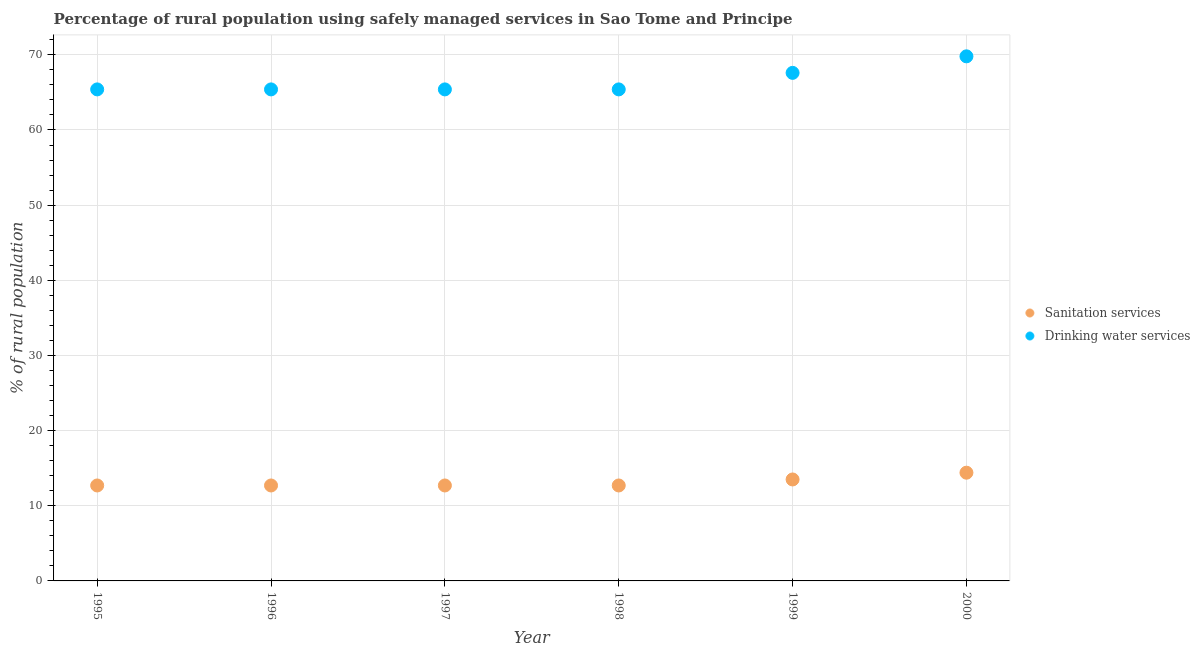How many different coloured dotlines are there?
Ensure brevity in your answer.  2. What is the percentage of rural population who used drinking water services in 2000?
Offer a terse response. 69.8. Across all years, what is the maximum percentage of rural population who used drinking water services?
Provide a short and direct response. 69.8. Across all years, what is the minimum percentage of rural population who used sanitation services?
Offer a terse response. 12.7. In which year was the percentage of rural population who used sanitation services minimum?
Your response must be concise. 1995. What is the total percentage of rural population who used drinking water services in the graph?
Ensure brevity in your answer.  399. What is the difference between the percentage of rural population who used drinking water services in 1995 and that in 1999?
Offer a terse response. -2.2. What is the difference between the percentage of rural population who used sanitation services in 2000 and the percentage of rural population who used drinking water services in 1995?
Your answer should be very brief. -51. What is the average percentage of rural population who used sanitation services per year?
Keep it short and to the point. 13.12. In the year 1997, what is the difference between the percentage of rural population who used sanitation services and percentage of rural population who used drinking water services?
Offer a very short reply. -52.7. What is the ratio of the percentage of rural population who used sanitation services in 1995 to that in 1998?
Provide a short and direct response. 1. Is the percentage of rural population who used drinking water services in 1995 less than that in 1999?
Keep it short and to the point. Yes. Is the difference between the percentage of rural population who used drinking water services in 1995 and 1998 greater than the difference between the percentage of rural population who used sanitation services in 1995 and 1998?
Your response must be concise. No. What is the difference between the highest and the second highest percentage of rural population who used drinking water services?
Make the answer very short. 2.2. What is the difference between the highest and the lowest percentage of rural population who used sanitation services?
Make the answer very short. 1.7. Does the percentage of rural population who used sanitation services monotonically increase over the years?
Provide a succinct answer. No. How many dotlines are there?
Your answer should be very brief. 2. What is the difference between two consecutive major ticks on the Y-axis?
Your answer should be very brief. 10. Are the values on the major ticks of Y-axis written in scientific E-notation?
Offer a terse response. No. Does the graph contain any zero values?
Make the answer very short. No. Does the graph contain grids?
Offer a very short reply. Yes. How many legend labels are there?
Keep it short and to the point. 2. What is the title of the graph?
Keep it short and to the point. Percentage of rural population using safely managed services in Sao Tome and Principe. Does "From production" appear as one of the legend labels in the graph?
Offer a terse response. No. What is the label or title of the Y-axis?
Your response must be concise. % of rural population. What is the % of rural population of Drinking water services in 1995?
Ensure brevity in your answer.  65.4. What is the % of rural population of Sanitation services in 1996?
Provide a short and direct response. 12.7. What is the % of rural population in Drinking water services in 1996?
Offer a very short reply. 65.4. What is the % of rural population of Drinking water services in 1997?
Provide a short and direct response. 65.4. What is the % of rural population of Drinking water services in 1998?
Your answer should be very brief. 65.4. What is the % of rural population in Sanitation services in 1999?
Offer a terse response. 13.5. What is the % of rural population in Drinking water services in 1999?
Offer a terse response. 67.6. What is the % of rural population in Sanitation services in 2000?
Provide a short and direct response. 14.4. What is the % of rural population in Drinking water services in 2000?
Keep it short and to the point. 69.8. Across all years, what is the maximum % of rural population in Drinking water services?
Offer a very short reply. 69.8. Across all years, what is the minimum % of rural population of Sanitation services?
Keep it short and to the point. 12.7. Across all years, what is the minimum % of rural population of Drinking water services?
Make the answer very short. 65.4. What is the total % of rural population in Sanitation services in the graph?
Provide a succinct answer. 78.7. What is the total % of rural population of Drinking water services in the graph?
Make the answer very short. 399. What is the difference between the % of rural population of Drinking water services in 1995 and that in 1996?
Your response must be concise. 0. What is the difference between the % of rural population in Sanitation services in 1995 and that in 1997?
Keep it short and to the point. 0. What is the difference between the % of rural population of Drinking water services in 1995 and that in 1997?
Give a very brief answer. 0. What is the difference between the % of rural population of Sanitation services in 1995 and that in 1998?
Keep it short and to the point. 0. What is the difference between the % of rural population in Sanitation services in 1995 and that in 1999?
Offer a terse response. -0.8. What is the difference between the % of rural population of Sanitation services in 1995 and that in 2000?
Offer a terse response. -1.7. What is the difference between the % of rural population of Drinking water services in 1995 and that in 2000?
Keep it short and to the point. -4.4. What is the difference between the % of rural population in Drinking water services in 1996 and that in 1997?
Provide a succinct answer. 0. What is the difference between the % of rural population of Sanitation services in 1996 and that in 1999?
Offer a very short reply. -0.8. What is the difference between the % of rural population in Sanitation services in 1997 and that in 2000?
Your response must be concise. -1.7. What is the difference between the % of rural population in Drinking water services in 1997 and that in 2000?
Your response must be concise. -4.4. What is the difference between the % of rural population in Sanitation services in 1999 and that in 2000?
Make the answer very short. -0.9. What is the difference between the % of rural population in Drinking water services in 1999 and that in 2000?
Provide a succinct answer. -2.2. What is the difference between the % of rural population of Sanitation services in 1995 and the % of rural population of Drinking water services in 1996?
Offer a very short reply. -52.7. What is the difference between the % of rural population of Sanitation services in 1995 and the % of rural population of Drinking water services in 1997?
Offer a terse response. -52.7. What is the difference between the % of rural population in Sanitation services in 1995 and the % of rural population in Drinking water services in 1998?
Offer a very short reply. -52.7. What is the difference between the % of rural population in Sanitation services in 1995 and the % of rural population in Drinking water services in 1999?
Provide a succinct answer. -54.9. What is the difference between the % of rural population in Sanitation services in 1995 and the % of rural population in Drinking water services in 2000?
Ensure brevity in your answer.  -57.1. What is the difference between the % of rural population in Sanitation services in 1996 and the % of rural population in Drinking water services in 1997?
Provide a succinct answer. -52.7. What is the difference between the % of rural population in Sanitation services in 1996 and the % of rural population in Drinking water services in 1998?
Provide a succinct answer. -52.7. What is the difference between the % of rural population of Sanitation services in 1996 and the % of rural population of Drinking water services in 1999?
Your answer should be compact. -54.9. What is the difference between the % of rural population in Sanitation services in 1996 and the % of rural population in Drinking water services in 2000?
Your response must be concise. -57.1. What is the difference between the % of rural population in Sanitation services in 1997 and the % of rural population in Drinking water services in 1998?
Provide a short and direct response. -52.7. What is the difference between the % of rural population in Sanitation services in 1997 and the % of rural population in Drinking water services in 1999?
Ensure brevity in your answer.  -54.9. What is the difference between the % of rural population in Sanitation services in 1997 and the % of rural population in Drinking water services in 2000?
Provide a short and direct response. -57.1. What is the difference between the % of rural population of Sanitation services in 1998 and the % of rural population of Drinking water services in 1999?
Keep it short and to the point. -54.9. What is the difference between the % of rural population of Sanitation services in 1998 and the % of rural population of Drinking water services in 2000?
Ensure brevity in your answer.  -57.1. What is the difference between the % of rural population in Sanitation services in 1999 and the % of rural population in Drinking water services in 2000?
Give a very brief answer. -56.3. What is the average % of rural population of Sanitation services per year?
Your response must be concise. 13.12. What is the average % of rural population in Drinking water services per year?
Your answer should be very brief. 66.5. In the year 1995, what is the difference between the % of rural population in Sanitation services and % of rural population in Drinking water services?
Your answer should be compact. -52.7. In the year 1996, what is the difference between the % of rural population in Sanitation services and % of rural population in Drinking water services?
Your answer should be compact. -52.7. In the year 1997, what is the difference between the % of rural population of Sanitation services and % of rural population of Drinking water services?
Your answer should be very brief. -52.7. In the year 1998, what is the difference between the % of rural population in Sanitation services and % of rural population in Drinking water services?
Your answer should be compact. -52.7. In the year 1999, what is the difference between the % of rural population of Sanitation services and % of rural population of Drinking water services?
Provide a short and direct response. -54.1. In the year 2000, what is the difference between the % of rural population in Sanitation services and % of rural population in Drinking water services?
Make the answer very short. -55.4. What is the ratio of the % of rural population in Sanitation services in 1995 to that in 1997?
Provide a short and direct response. 1. What is the ratio of the % of rural population in Drinking water services in 1995 to that in 1997?
Ensure brevity in your answer.  1. What is the ratio of the % of rural population of Sanitation services in 1995 to that in 1998?
Your answer should be very brief. 1. What is the ratio of the % of rural population of Drinking water services in 1995 to that in 1998?
Provide a succinct answer. 1. What is the ratio of the % of rural population in Sanitation services in 1995 to that in 1999?
Make the answer very short. 0.94. What is the ratio of the % of rural population in Drinking water services in 1995 to that in 1999?
Provide a succinct answer. 0.97. What is the ratio of the % of rural population in Sanitation services in 1995 to that in 2000?
Keep it short and to the point. 0.88. What is the ratio of the % of rural population of Drinking water services in 1995 to that in 2000?
Make the answer very short. 0.94. What is the ratio of the % of rural population in Drinking water services in 1996 to that in 1997?
Offer a very short reply. 1. What is the ratio of the % of rural population of Sanitation services in 1996 to that in 1998?
Your answer should be very brief. 1. What is the ratio of the % of rural population in Drinking water services in 1996 to that in 1998?
Your response must be concise. 1. What is the ratio of the % of rural population of Sanitation services in 1996 to that in 1999?
Offer a very short reply. 0.94. What is the ratio of the % of rural population of Drinking water services in 1996 to that in 1999?
Offer a very short reply. 0.97. What is the ratio of the % of rural population of Sanitation services in 1996 to that in 2000?
Provide a succinct answer. 0.88. What is the ratio of the % of rural population of Drinking water services in 1996 to that in 2000?
Your response must be concise. 0.94. What is the ratio of the % of rural population of Sanitation services in 1997 to that in 1999?
Make the answer very short. 0.94. What is the ratio of the % of rural population in Drinking water services in 1997 to that in 1999?
Give a very brief answer. 0.97. What is the ratio of the % of rural population in Sanitation services in 1997 to that in 2000?
Provide a short and direct response. 0.88. What is the ratio of the % of rural population in Drinking water services in 1997 to that in 2000?
Your answer should be very brief. 0.94. What is the ratio of the % of rural population of Sanitation services in 1998 to that in 1999?
Make the answer very short. 0.94. What is the ratio of the % of rural population of Drinking water services in 1998 to that in 1999?
Keep it short and to the point. 0.97. What is the ratio of the % of rural population in Sanitation services in 1998 to that in 2000?
Ensure brevity in your answer.  0.88. What is the ratio of the % of rural population of Drinking water services in 1998 to that in 2000?
Your answer should be compact. 0.94. What is the ratio of the % of rural population in Sanitation services in 1999 to that in 2000?
Offer a terse response. 0.94. What is the ratio of the % of rural population in Drinking water services in 1999 to that in 2000?
Provide a short and direct response. 0.97. What is the difference between the highest and the lowest % of rural population in Drinking water services?
Your response must be concise. 4.4. 